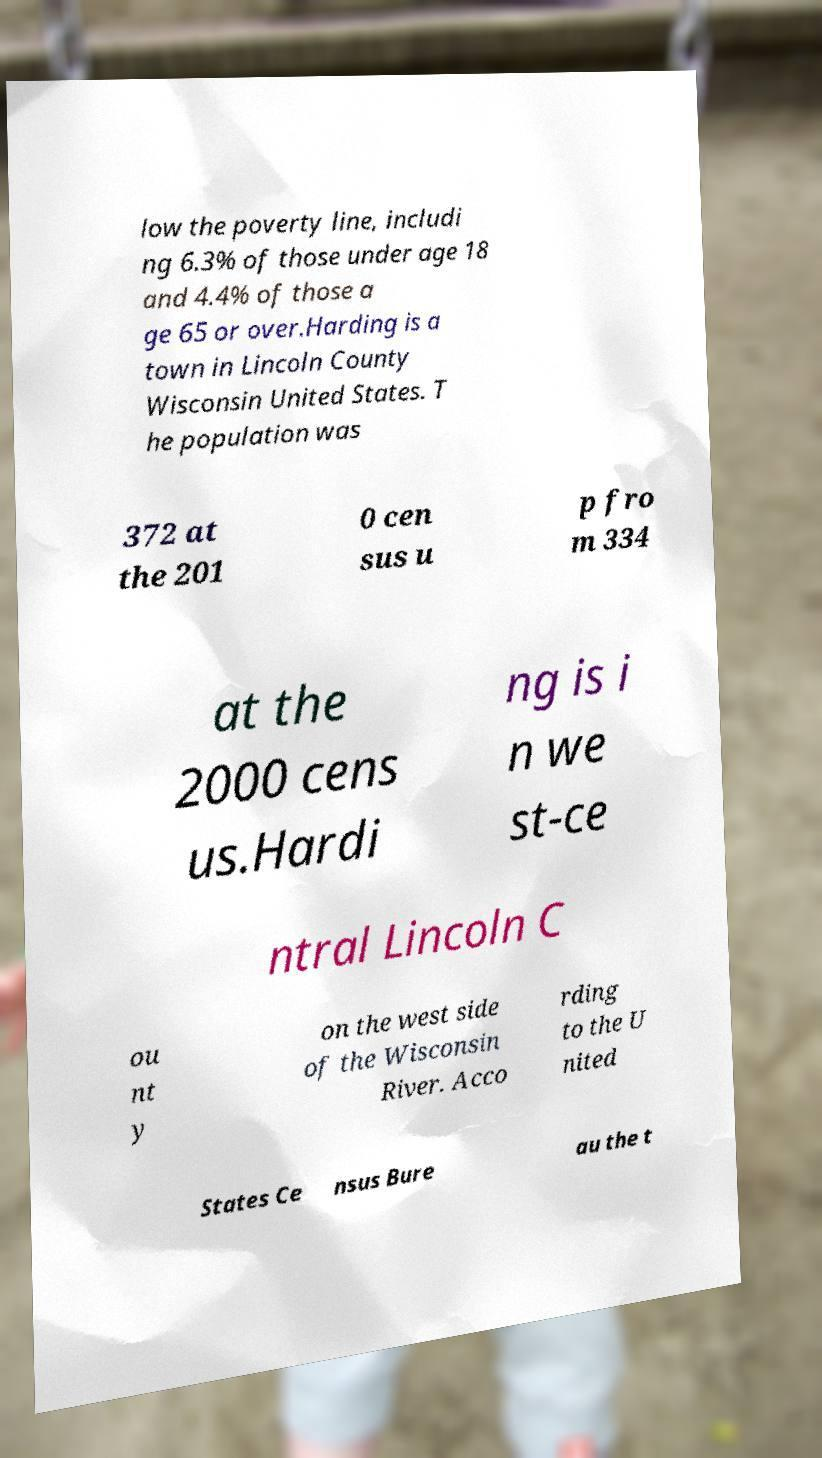Could you assist in decoding the text presented in this image and type it out clearly? low the poverty line, includi ng 6.3% of those under age 18 and 4.4% of those a ge 65 or over.Harding is a town in Lincoln County Wisconsin United States. T he population was 372 at the 201 0 cen sus u p fro m 334 at the 2000 cens us.Hardi ng is i n we st-ce ntral Lincoln C ou nt y on the west side of the Wisconsin River. Acco rding to the U nited States Ce nsus Bure au the t 